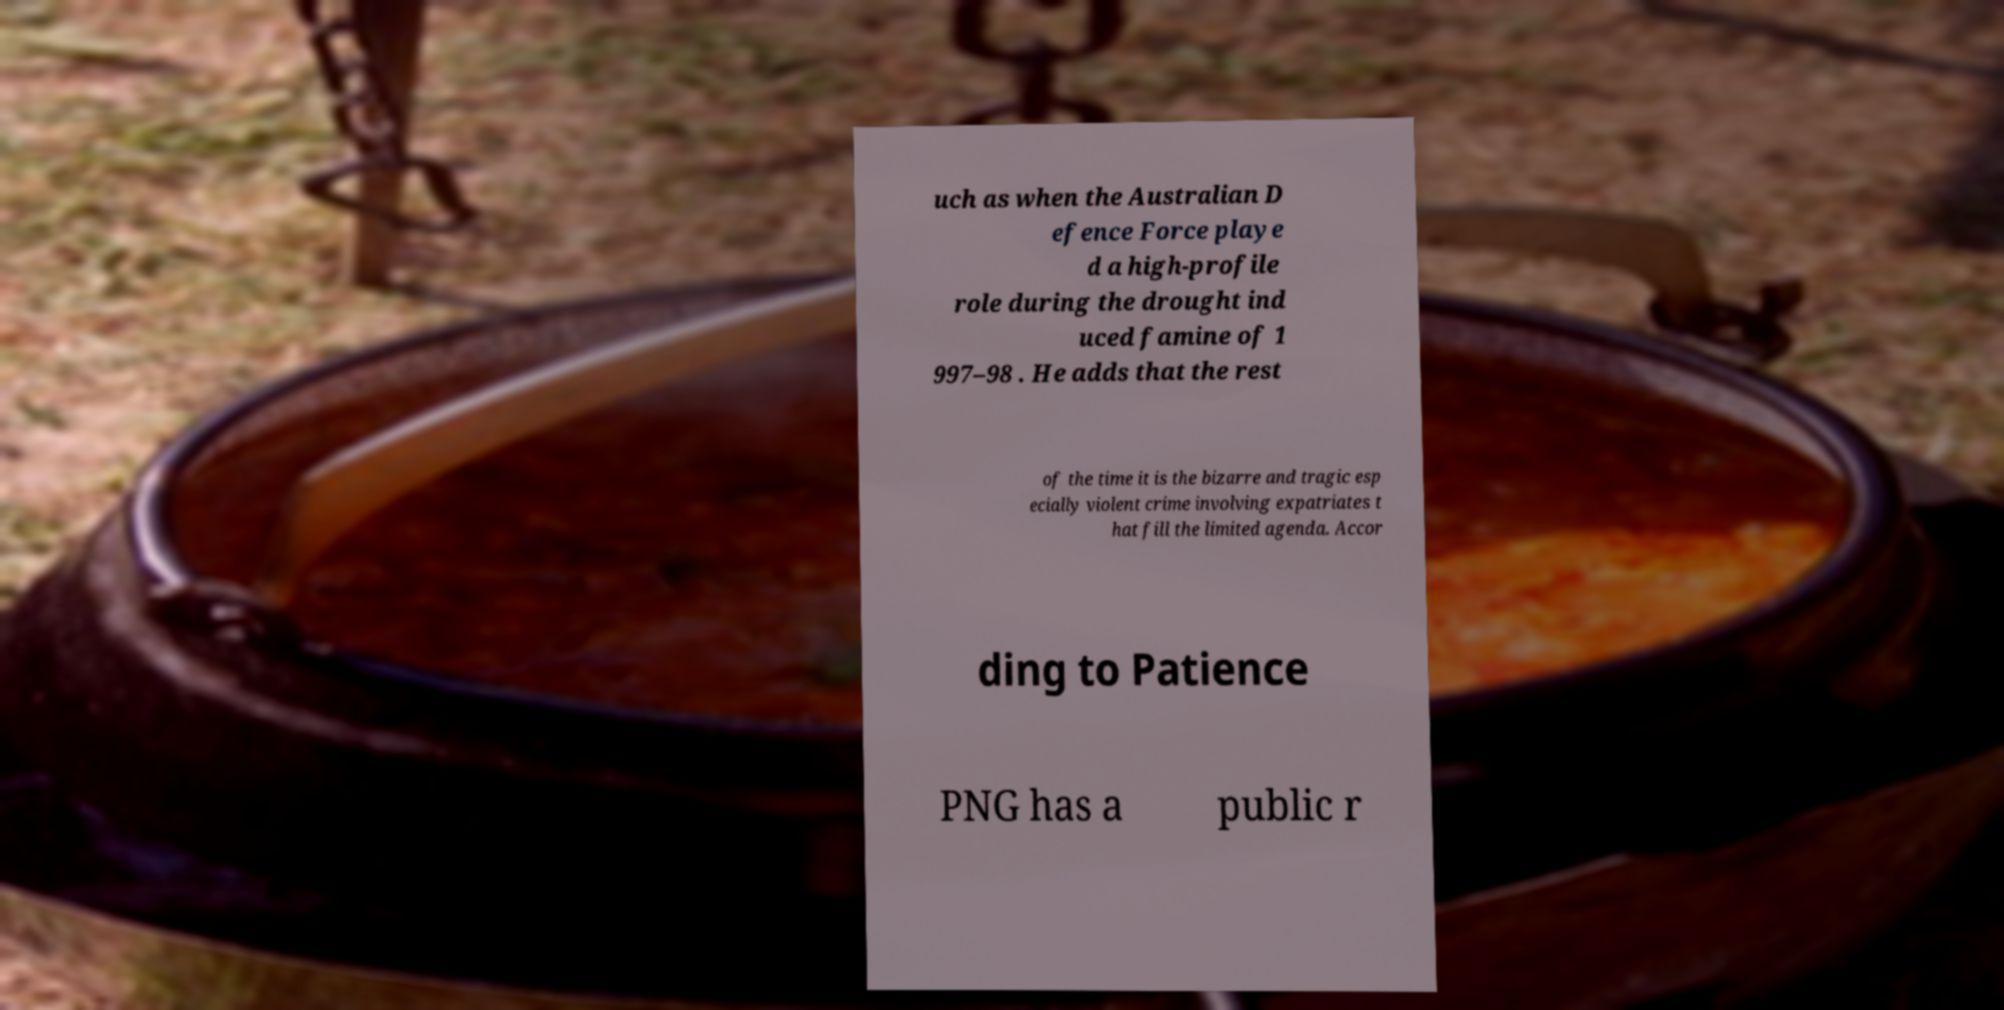What messages or text are displayed in this image? I need them in a readable, typed format. uch as when the Australian D efence Force playe d a high-profile role during the drought ind uced famine of 1 997–98 . He adds that the rest of the time it is the bizarre and tragic esp ecially violent crime involving expatriates t hat fill the limited agenda. Accor ding to Patience PNG has a public r 